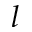Convert formula to latex. <formula><loc_0><loc_0><loc_500><loc_500>l</formula> 